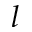Convert formula to latex. <formula><loc_0><loc_0><loc_500><loc_500>l</formula> 